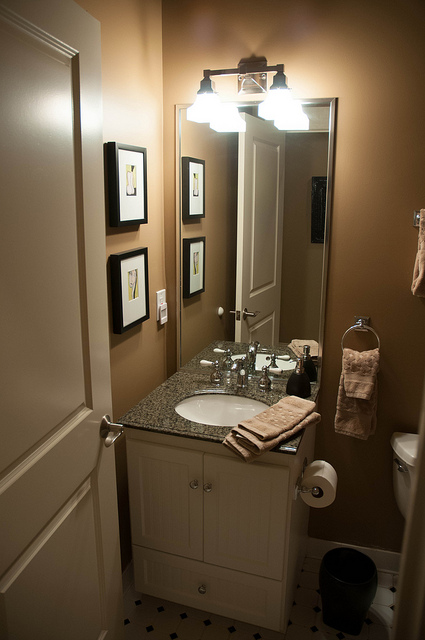<image>What piece of furniture is on the other side of the door? I don't know what piece of furniture is on the other side of the door. It could be a variety of things such as a cabinet, vanity, countertop, toilet, table, chair, or a painting. What piece of furniture is on the other side of the door? I don't know what piece of furniture is on the other side of the door. It could be a cabinet, vanity, countertop, toilet, table, chair, or painting. 